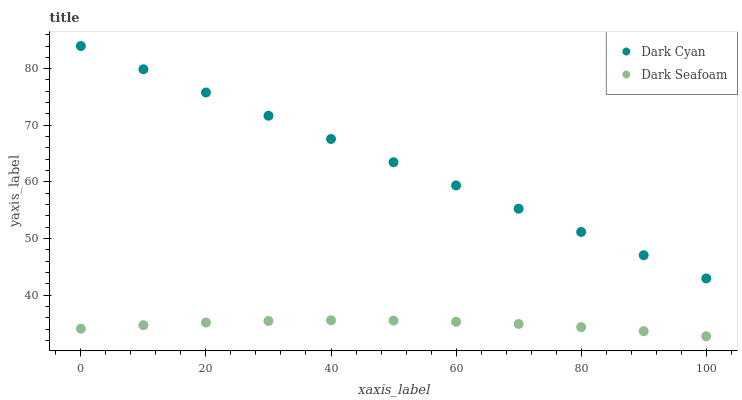Does Dark Seafoam have the minimum area under the curve?
Answer yes or no. Yes. Does Dark Cyan have the maximum area under the curve?
Answer yes or no. Yes. Does Dark Seafoam have the maximum area under the curve?
Answer yes or no. No. Is Dark Cyan the smoothest?
Answer yes or no. Yes. Is Dark Seafoam the roughest?
Answer yes or no. Yes. Is Dark Seafoam the smoothest?
Answer yes or no. No. Does Dark Seafoam have the lowest value?
Answer yes or no. Yes. Does Dark Cyan have the highest value?
Answer yes or no. Yes. Does Dark Seafoam have the highest value?
Answer yes or no. No. Is Dark Seafoam less than Dark Cyan?
Answer yes or no. Yes. Is Dark Cyan greater than Dark Seafoam?
Answer yes or no. Yes. Does Dark Seafoam intersect Dark Cyan?
Answer yes or no. No. 